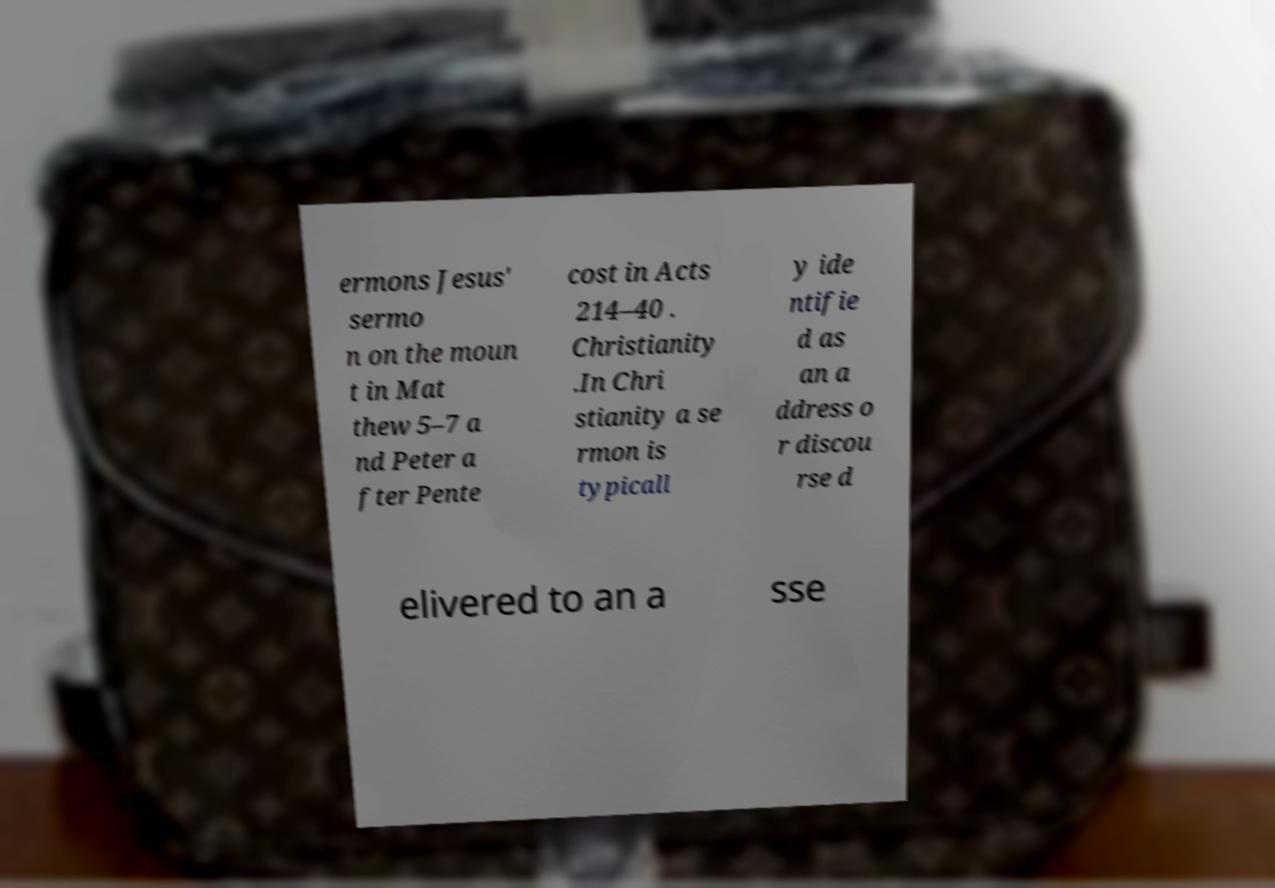For documentation purposes, I need the text within this image transcribed. Could you provide that? ermons Jesus' sermo n on the moun t in Mat thew 5–7 a nd Peter a fter Pente cost in Acts 214–40 . Christianity .In Chri stianity a se rmon is typicall y ide ntifie d as an a ddress o r discou rse d elivered to an a sse 